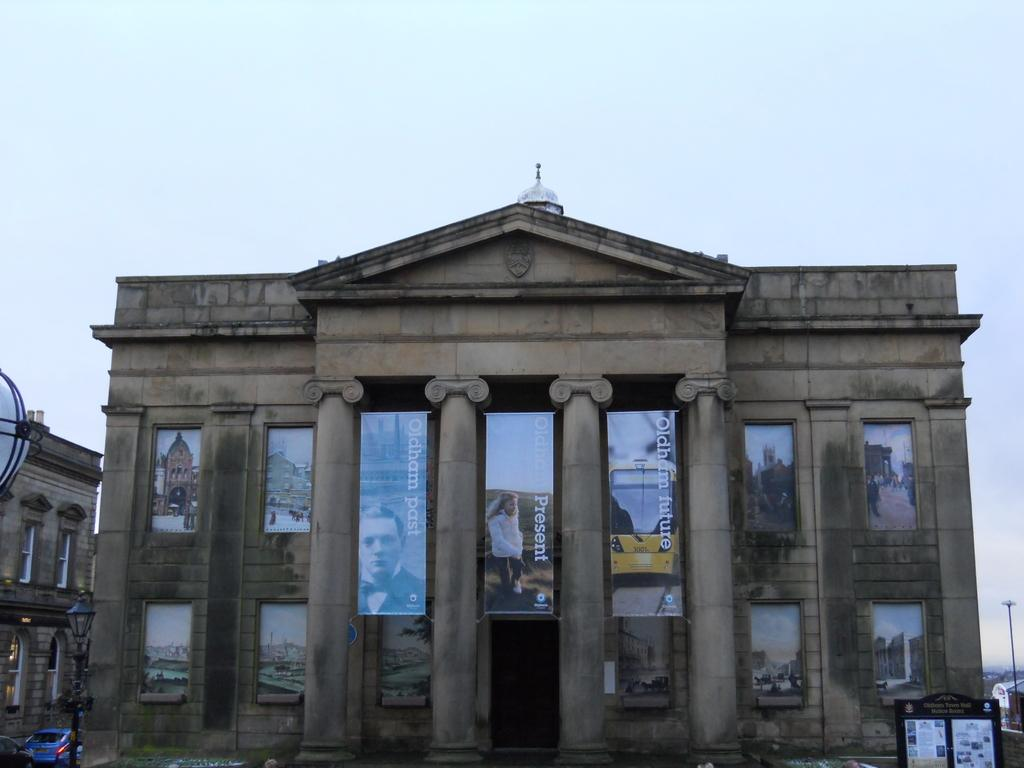What type of structures can be seen in the image? There are buildings in the image. What is hanging from one of the buildings? Banners are hanging from a building. What type of lighting is present in the image? There are pole lights in the image. What type of vehicles can be seen in the image? Cars are moving in the image. What is the weather like in the image? The sky is cloudy in the image. What is the purpose of the board in the image? The purpose of the board in the image is not specified, but it could be used for displaying information or advertisements. What is the spark of interest generated by the expansion of the buildings in the image? There is no mention of expansion in the image, and therefore no spark of interest can be generated by it. 